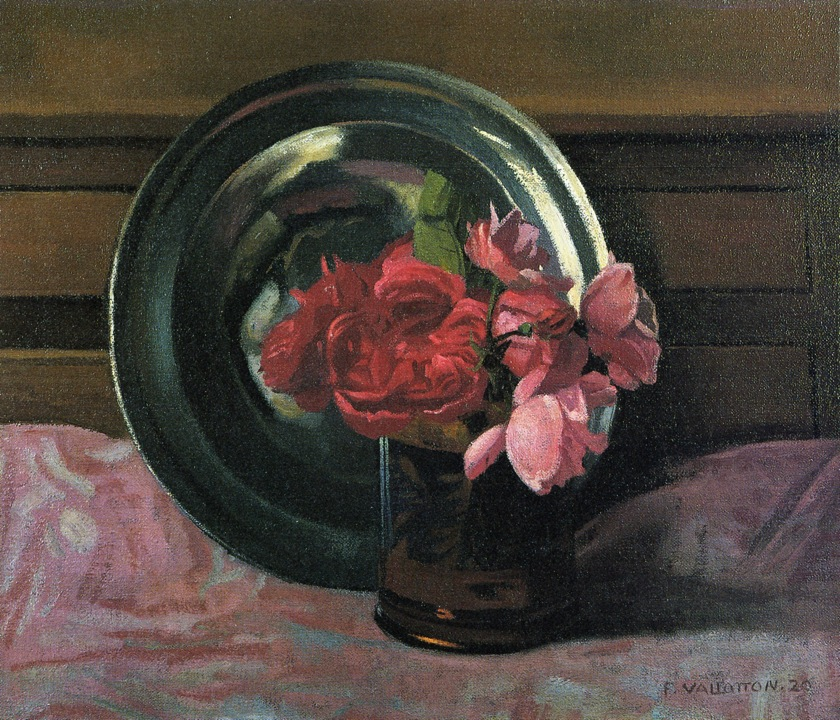Can you describe the mood conveyed by this painting? The mood of the painting is serene and contemplative. The delicate roses in rich red and pink hues evoke feelings of calm and refined beauty, while the muted background and gentle lighting contribute to an overall sense of tranquility. The meticulous detailing and the still-life composition suggest a moment of peaceful reflection, inviting the viewer to pause and appreciate the simple yet profound beauty of the scene. 